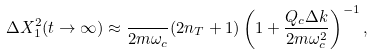<formula> <loc_0><loc_0><loc_500><loc_500>\Delta X _ { 1 } ^ { 2 } ( t \rightarrow \infty ) \approx \frac { } { 2 m \omega _ { c } } ( 2 n _ { T } + 1 ) \left ( 1 + \frac { Q _ { c } \Delta k } { 2 m \omega ^ { 2 } _ { c } } \right ) ^ { - 1 } ,</formula> 